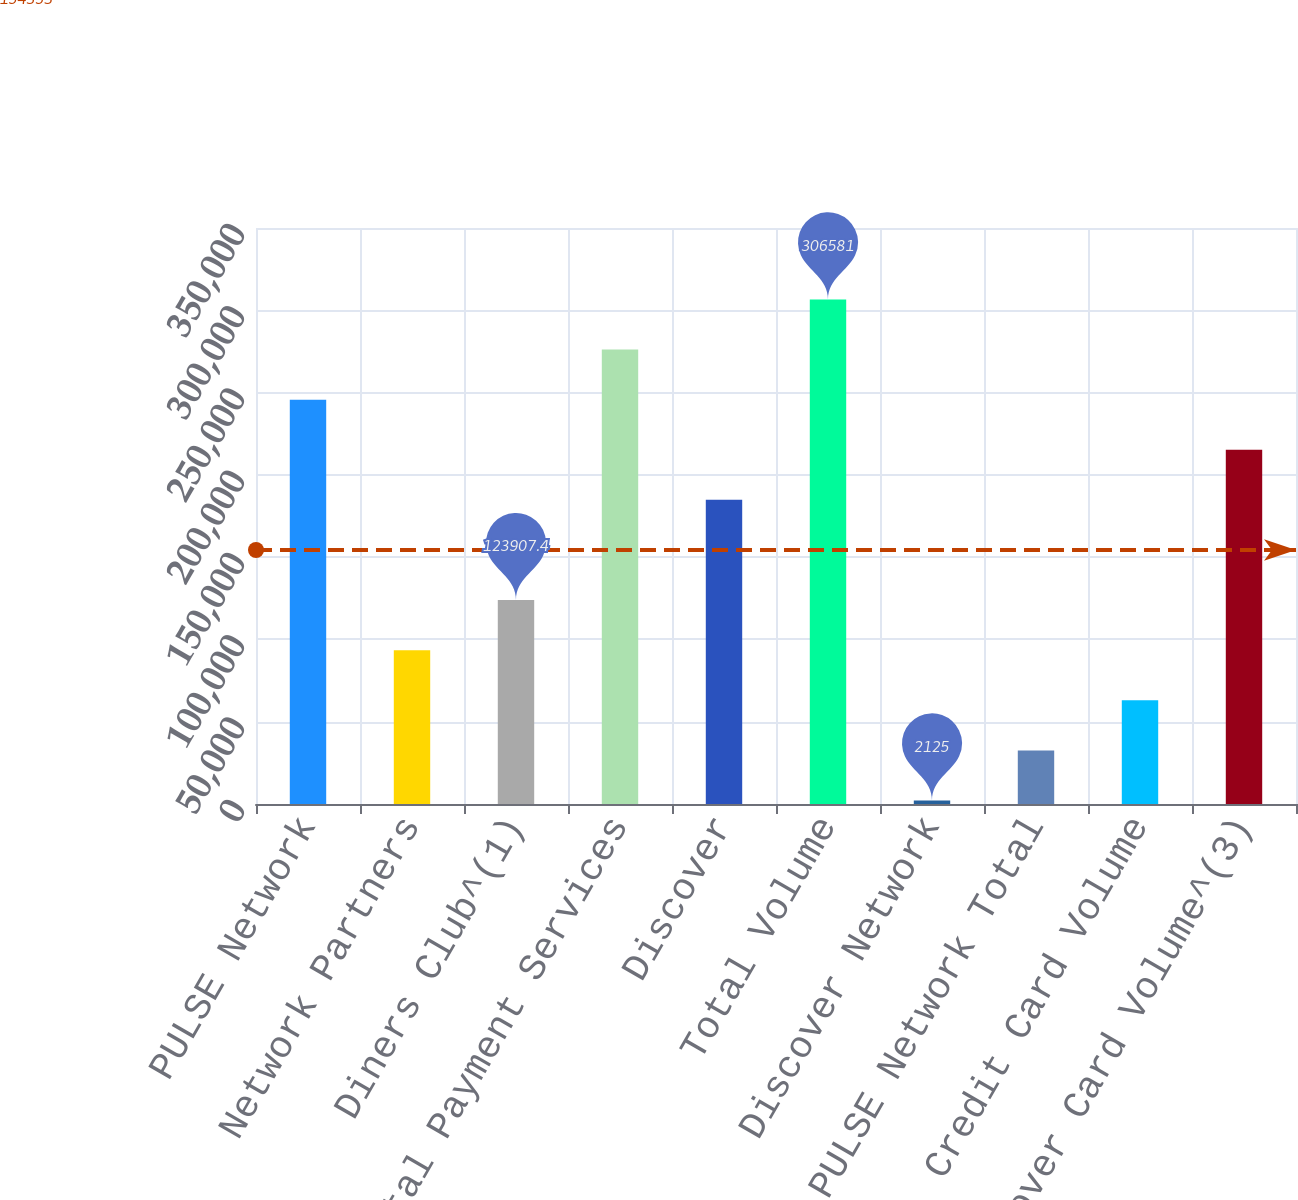Convert chart. <chart><loc_0><loc_0><loc_500><loc_500><bar_chart><fcel>PULSE Network<fcel>Network Partners<fcel>Diners Club^(1)<fcel>Total Payment Services<fcel>Discover<fcel>Total Volume<fcel>Discover Network<fcel>PULSE Network Total<fcel>Credit Card Volume<fcel>Discover Card Volume^(3)<nl><fcel>245690<fcel>93461.8<fcel>123907<fcel>276135<fcel>184799<fcel>306581<fcel>2125<fcel>32570.6<fcel>63016.2<fcel>215244<nl></chart> 